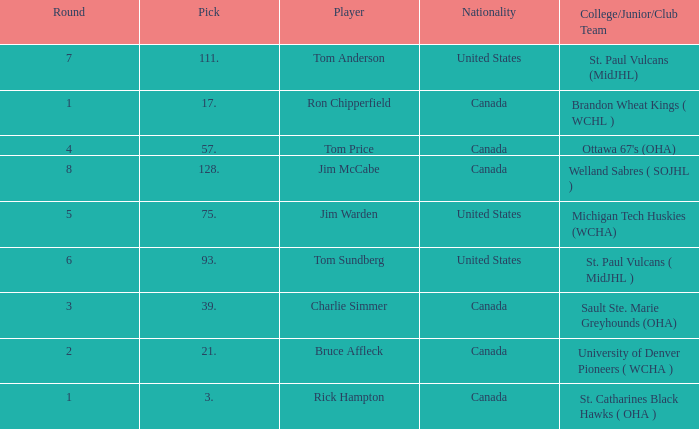Can you tell me the College/Junior/Club Team that has the Round of 4? Ottawa 67's (OHA). 